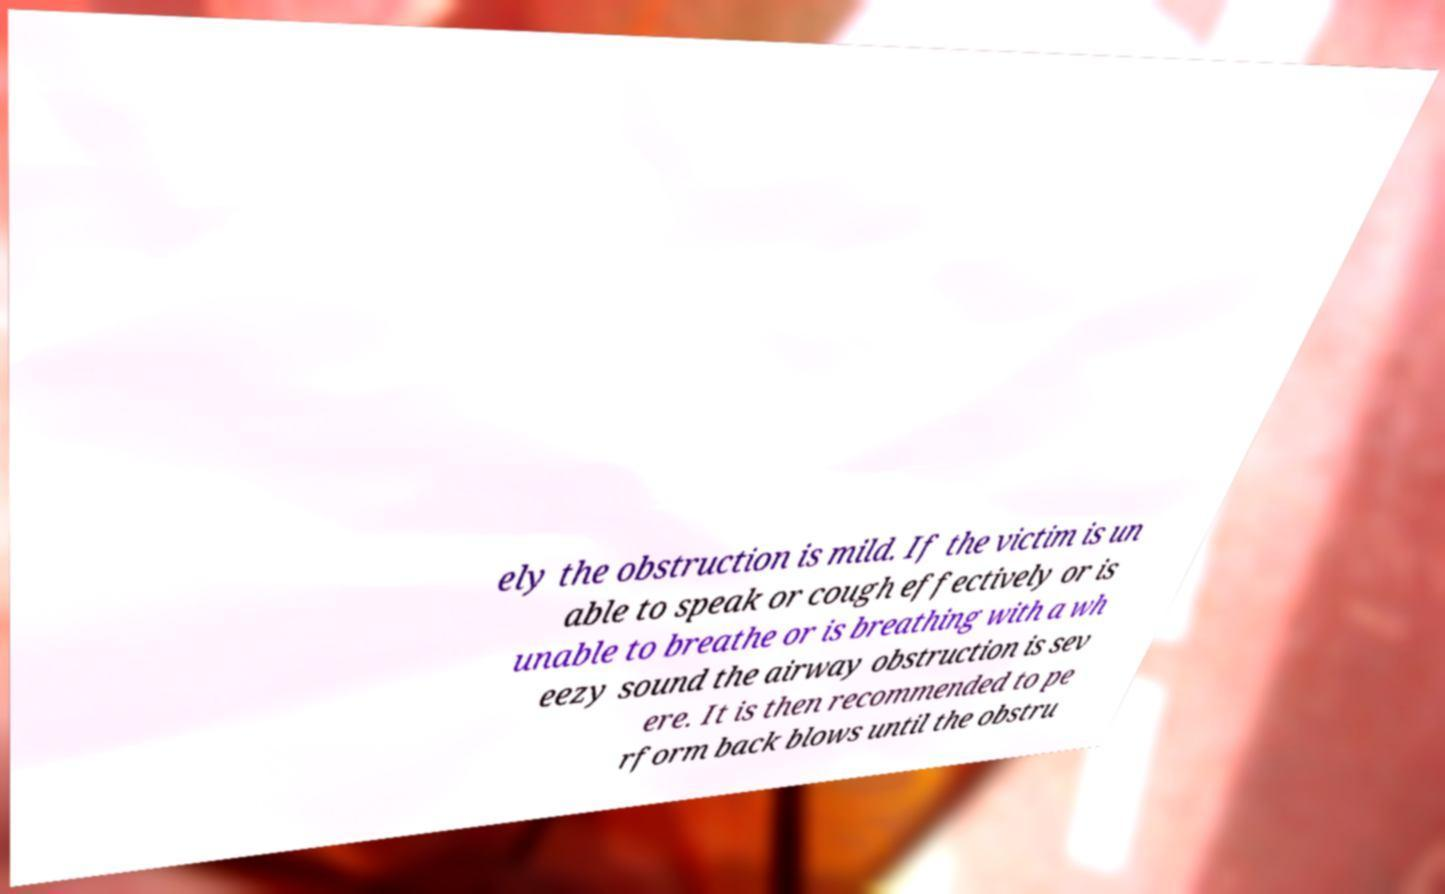I need the written content from this picture converted into text. Can you do that? ely the obstruction is mild. If the victim is un able to speak or cough effectively or is unable to breathe or is breathing with a wh eezy sound the airway obstruction is sev ere. It is then recommended to pe rform back blows until the obstru 